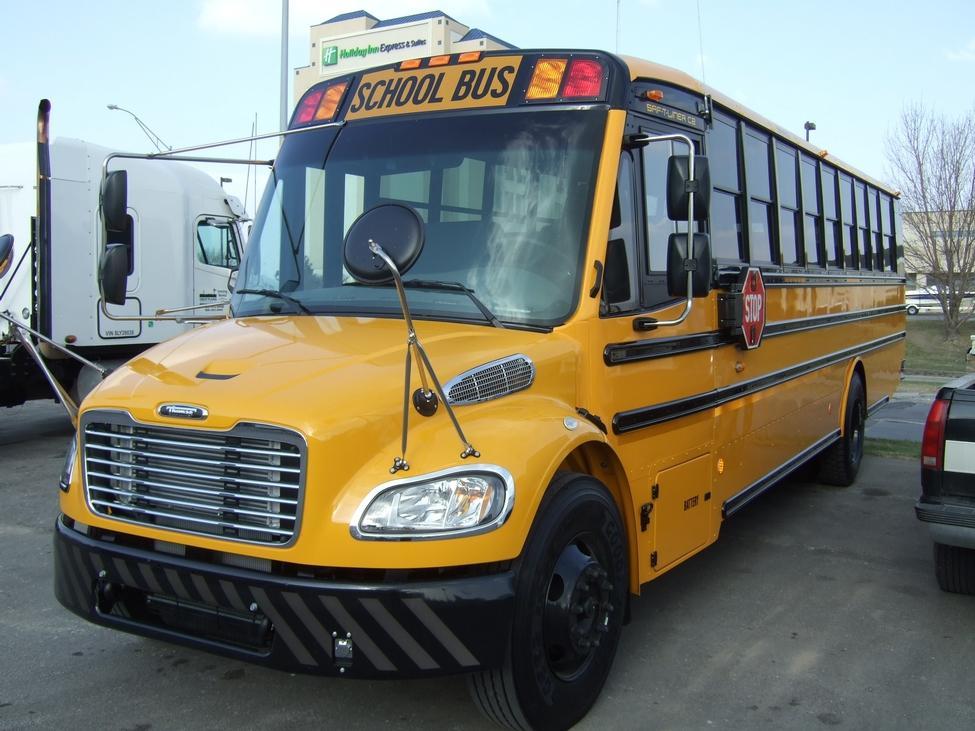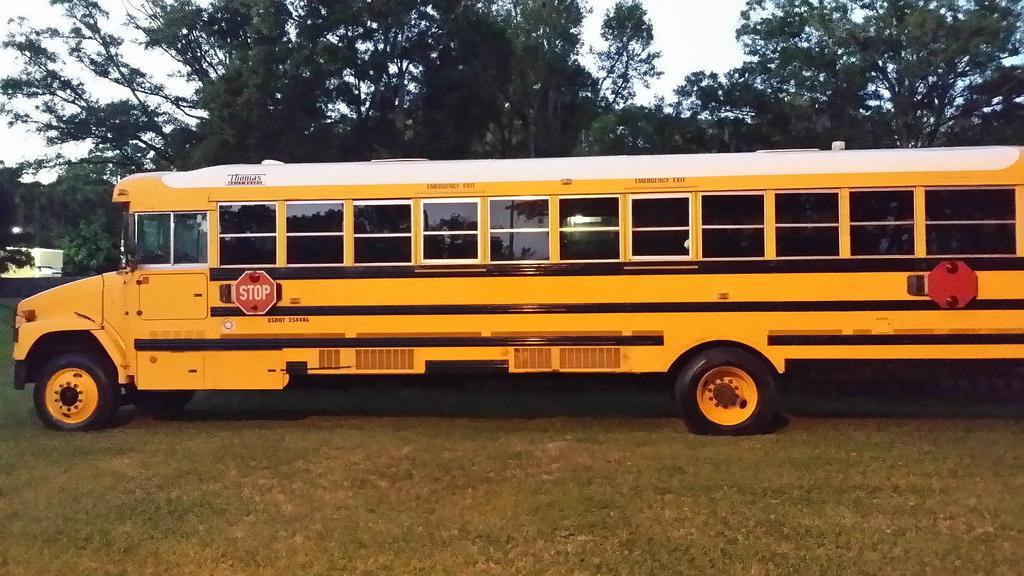The first image is the image on the left, the second image is the image on the right. Examine the images to the left and right. Is the description "All the school buses in the images are facing to the left." accurate? Answer yes or no. Yes. The first image is the image on the left, the second image is the image on the right. Given the left and right images, does the statement "One of the images features two school buses beside each other." hold true? Answer yes or no. No. 